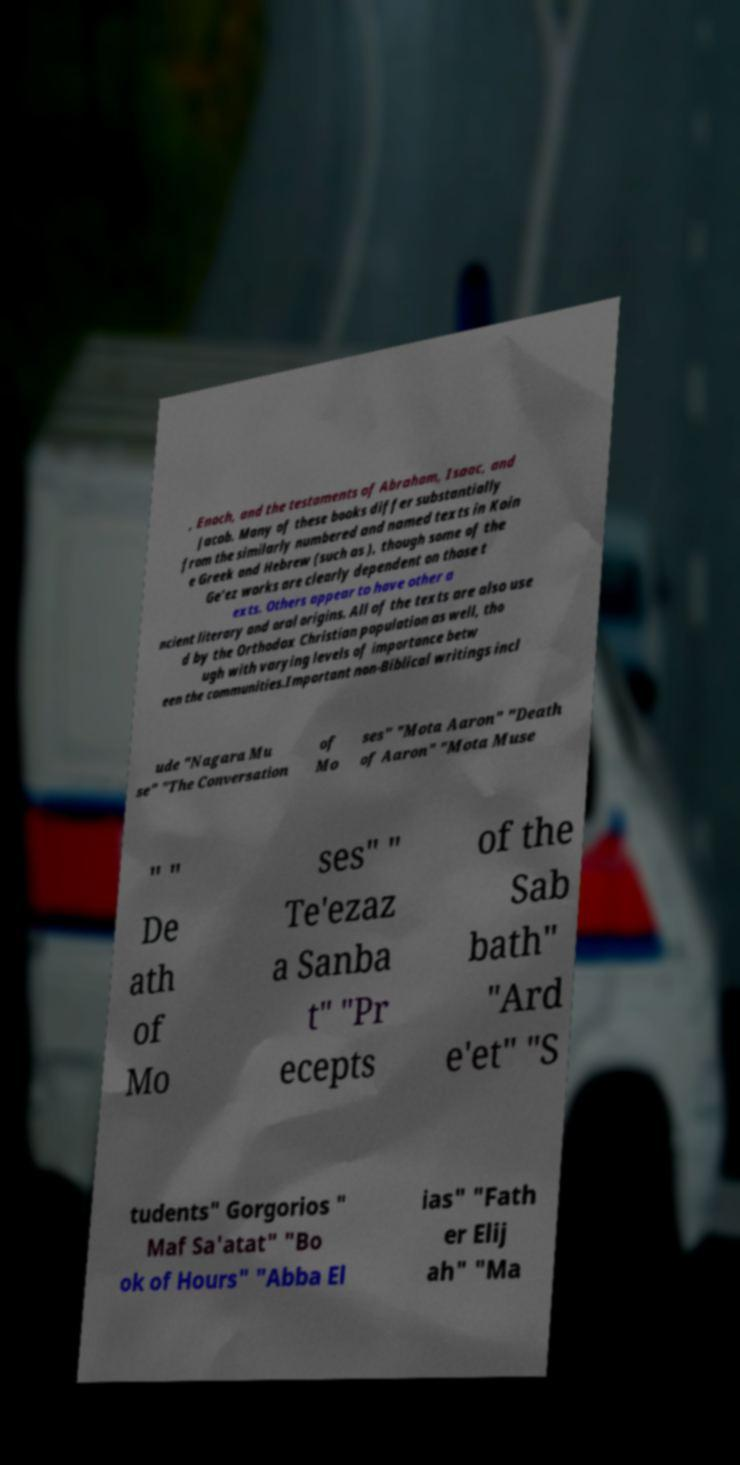Could you assist in decoding the text presented in this image and type it out clearly? , Enoch, and the testaments of Abraham, Isaac, and Jacob. Many of these books differ substantially from the similarly numbered and named texts in Koin e Greek and Hebrew (such as ), though some of the Ge'ez works are clearly dependent on those t exts. Others appear to have other a ncient literary and oral origins. All of the texts are also use d by the Orthodox Christian population as well, tho ugh with varying levels of importance betw een the communities.Important non-Biblical writings incl ude "Nagara Mu se" "The Conversation of Mo ses" "Mota Aaron" "Death of Aaron" "Mota Muse " " De ath of Mo ses" " Te'ezaz a Sanba t" "Pr ecepts of the Sab bath" "Ard e'et" "S tudents" Gorgorios " Maf Sa'atat" "Bo ok of Hours" "Abba El ias" "Fath er Elij ah" "Ma 